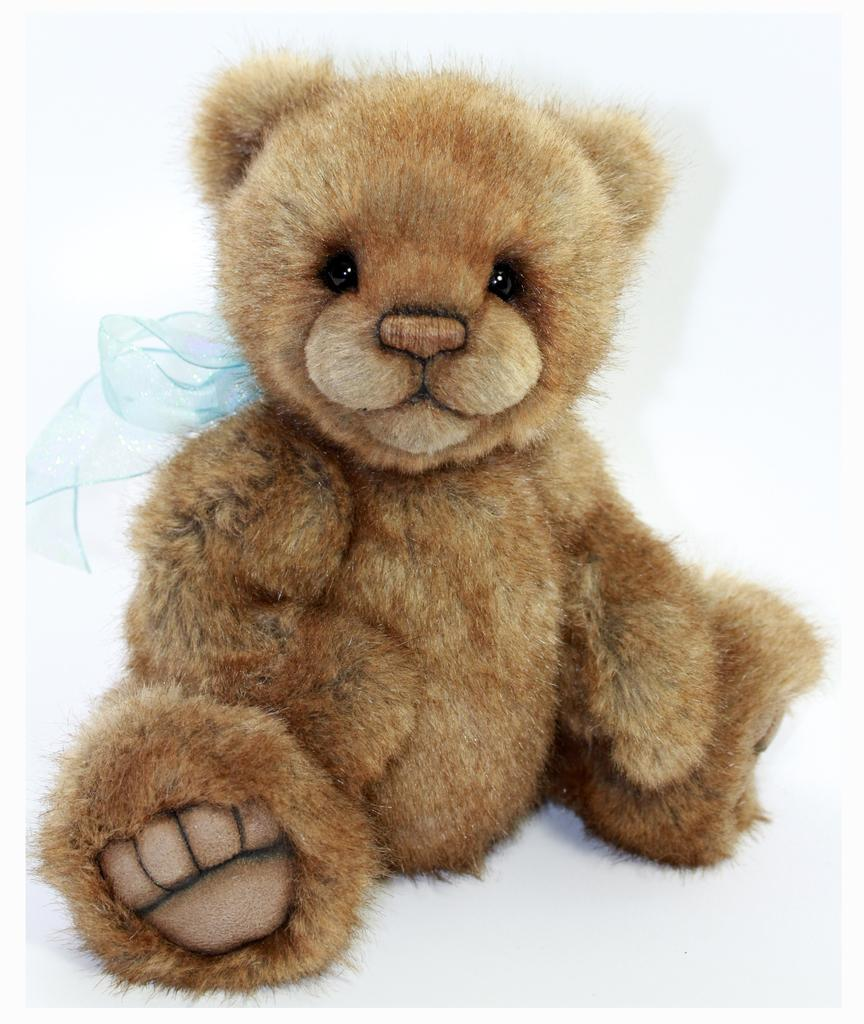What type of object can be seen in the image? There is a soft toy in the image. What type of verse is written on the soft toy in the image? There is no verse written on the soft toy in the image. Is the soft toy wearing a hat in the image? There is no hat visible on the soft toy in the image. 